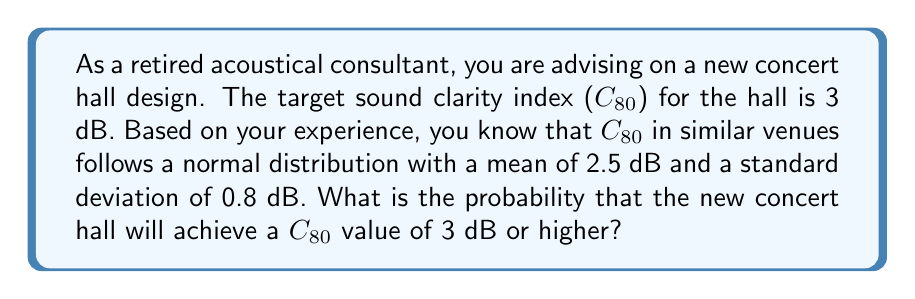Help me with this question. To solve this problem, we need to use the properties of the normal distribution and calculate the z-score for the target C80 value. Then, we can use the standard normal distribution table or a calculator to find the probability.

Given:
- Target C80 = 3 dB
- Mean (μ) = 2.5 dB
- Standard deviation (σ) = 0.8 dB

Step 1: Calculate the z-score
The z-score represents how many standard deviations the target value is from the mean.

$$ z = \frac{x - \mu}{\sigma} $$

Where:
x = target value
μ = mean
σ = standard deviation

$$ z = \frac{3 - 2.5}{0.8} = \frac{0.5}{0.8} = 0.625 $$

Step 2: Find the probability
We want to find P(C80 ≥ 3 dB), which is equivalent to finding the area under the standard normal curve to the right of z = 0.625.

Using a standard normal distribution table or calculator, we can find that:

P(Z > 0.625) ≈ 0.2660

Step 3: Interpret the result
The probability of achieving a C80 value of 3 dB or higher is approximately 0.2660 or 26.60%.
Answer: The probability of achieving a C80 value of 3 dB or higher in the new concert hall is approximately 0.2660 or 26.60%. 